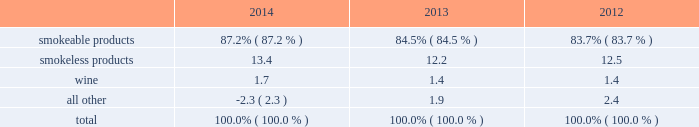Part i item 1 .
Business .
General development of business general : altria group , inc .
Is a holding company incorporated in the commonwealth of virginia in 1985 .
At december 31 , 2014 , altria group , inc . 2019s wholly-owned subsidiaries included philip morris usa inc .
( 201cpm usa 201d ) , which is engaged predominantly in the manufacture and sale of cigarettes in the united states ; john middleton co .
( 201cmiddleton 201d ) , which is engaged in the manufacture and sale of machine-made large cigars and pipe tobacco , and is a wholly- owned subsidiary of pm usa ; and ust llc ( 201cust 201d ) , which through its wholly-owned subsidiaries , including u.s .
Smokeless tobacco company llc ( 201cusstc 201d ) and ste .
Michelle wine estates ltd .
( 201cste .
Michelle 201d ) , is engaged in the manufacture and sale of smokeless tobacco products and wine .
Altria group , inc . 2019s other operating companies included nu mark llc ( 201cnu mark 201d ) , a wholly-owned subsidiary that is engaged in the manufacture and sale of innovative tobacco products , and philip morris capital corporation ( 201cpmcc 201d ) , a wholly-owned subsidiary that maintains a portfolio of finance assets , substantially all of which are leveraged leases .
Other altria group , inc .
Wholly-owned subsidiaries included altria group distribution company , which provides sales , distribution and consumer engagement services to certain altria group , inc .
Operating subsidiaries , and altria client services inc. , which provides various support services , such as legal , regulatory , finance , human resources and external affairs , to altria group , inc .
And its subsidiaries .
At december 31 , 2014 , altria group , inc .
Also held approximately 27% ( 27 % ) of the economic and voting interest of sabmiller plc ( 201csabmiller 201d ) , which altria group , inc .
Accounts for under the equity method of accounting .
Source of funds : because altria group , inc .
Is a holding company , its access to the operating cash flows of its wholly- owned subsidiaries consists of cash received from the payment of dividends and distributions , and the payment of interest on intercompany loans by its subsidiaries .
At december 31 , 2014 , altria group , inc . 2019s principal wholly-owned subsidiaries were not limited by long-term debt or other agreements in their ability to pay cash dividends or make other distributions with respect to their equity interests .
In addition , altria group , inc .
Receives cash dividends on its interest in sabmiller if and when sabmiller pays such dividends .
Financial information about segments altria group , inc . 2019s reportable segments are smokeable products , smokeless products and wine .
The financial services and the innovative tobacco products businesses are included in an all other category due to the continued reduction of the lease portfolio of pmcc and the relative financial contribution of altria group , inc . 2019s innovative tobacco products businesses to altria group , inc . 2019s consolidated results .
Altria group , inc . 2019s chief operating decision maker reviews operating companies income to evaluate the performance of , and allocate resources to , the segments .
Operating companies income for the segments is defined as operating income before amortization of intangibles and general corporate expenses .
Interest and other debt expense , net , and provision for income taxes are centrally managed at the corporate level and , accordingly , such items are not presented by segment since they are excluded from the measure of segment profitability reviewed by altria group , inc . 2019s chief operating decision maker .
Net revenues and operating companies income ( together with a reconciliation to earnings before income taxes ) attributable to each such segment for each of the last three years are set forth in note 15 .
Segment reporting to the consolidated financial statements in item 8 .
Financial statements and supplementary data of this annual report on form 10-k ( 201citem 8 201d ) .
Information about total assets by segment is not disclosed because such information is not reported to or used by altria group , inc . 2019s chief operating decision maker .
Segment goodwill and other intangible assets , net , are disclosed in note 4 .
Goodwill and other intangible assets , net to the consolidated financial statements in item 8 ( 201cnote 4 201d ) .
The accounting policies of the segments are the same as those described in note 2 .
Summary of significant accounting policies to the consolidated financial statements in item 8 ( 201cnote 2 201d ) .
The relative percentages of operating companies income ( loss ) attributable to each reportable segment and the all other category were as follows: .
For items affecting the comparability of the relative percentages of operating companies income ( loss ) attributable to each reportable segment , see note 15 .
Segment reporting to the consolidated financial statements in item 8 ( 201cnote 15 201d ) .
Narrative description of business portions of the information called for by this item are included in item 7 .
Management 2019s discussion and analysis of financial condition and results of operations - operating results by business segment of this annual report on form 10-k .
Tobacco space altria group , inc . 2019s tobacco operating companies include pm usa , usstc and other subsidiaries of ust , middleton and nu mark .
Altria group distribution company provides sales , distribution and consumer engagement services to altria group , inc . 2019s tobacco operating companies .
The products of altria group , inc . 2019s tobacco subsidiaries include smokeable tobacco products comprised of cigarettes manufactured and sold by pm usa and machine-made large altria_mdc_2014form10k_nolinks_crops.pdf 3 2/25/15 5:56 pm .
How did the percentage of operating income related to smokeless product change from 2012 to 2013 relative the total operating income? 
Computations: ((12.2 - 12.5) / 12.5)
Answer: -0.024. 